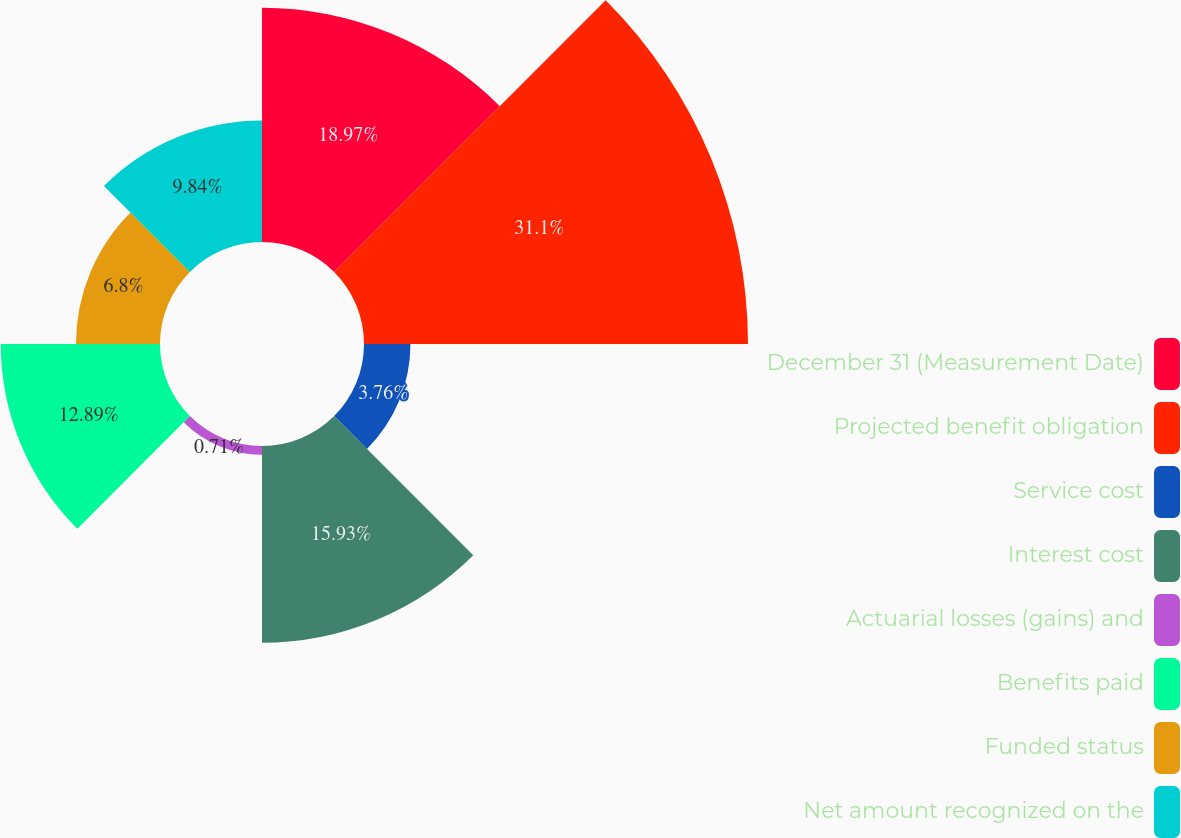Convert chart to OTSL. <chart><loc_0><loc_0><loc_500><loc_500><pie_chart><fcel>December 31 (Measurement Date)<fcel>Projected benefit obligation<fcel>Service cost<fcel>Interest cost<fcel>Actuarial losses (gains) and<fcel>Benefits paid<fcel>Funded status<fcel>Net amount recognized on the<nl><fcel>18.97%<fcel>31.09%<fcel>3.76%<fcel>15.93%<fcel>0.71%<fcel>12.89%<fcel>6.8%<fcel>9.84%<nl></chart> 